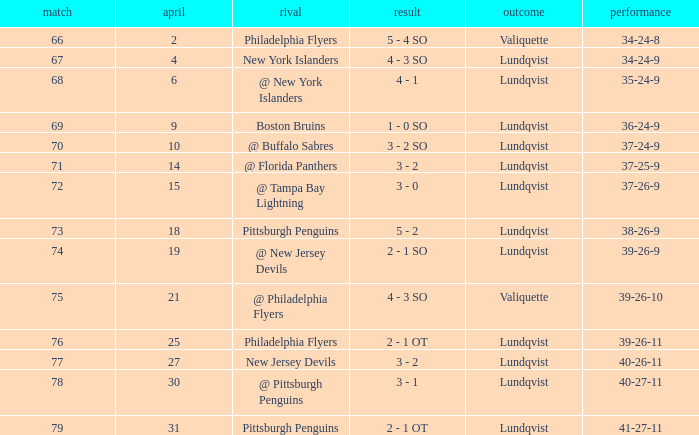Which opponent's game was less than 76 when the march was 10? @ Buffalo Sabres. 